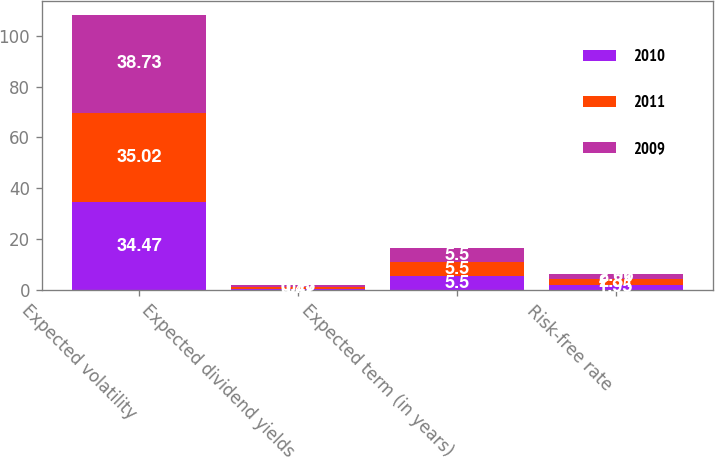Convert chart. <chart><loc_0><loc_0><loc_500><loc_500><stacked_bar_chart><ecel><fcel>Expected volatility<fcel>Expected dividend yields<fcel>Expected term (in years)<fcel>Risk-free rate<nl><fcel>2010<fcel>34.47<fcel>0.47<fcel>5.5<fcel>1.95<nl><fcel>2011<fcel>35.02<fcel>0.6<fcel>5.5<fcel>2.31<nl><fcel>2009<fcel>38.73<fcel>0.73<fcel>5.5<fcel>2.06<nl></chart> 